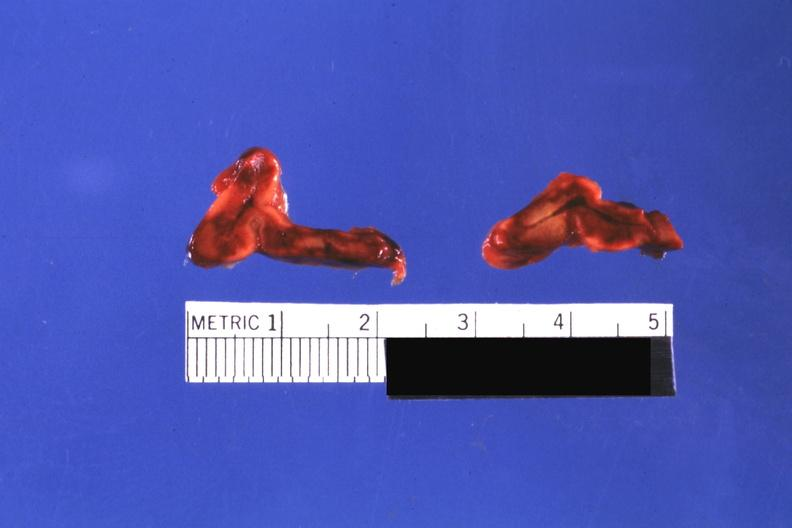what looks like placental abruption?
Answer the question using a single word or phrase. Cut surfaces of both adrenals focal hemorrhagic infarction well shown do not know history 